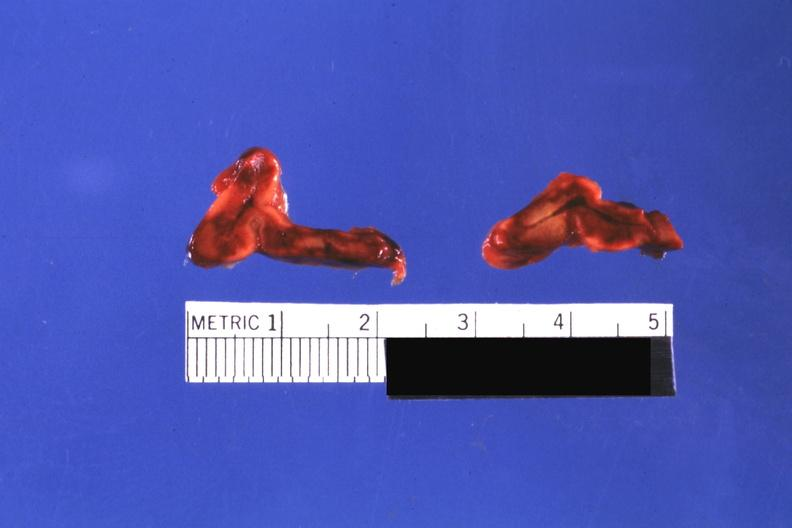what looks like placental abruption?
Answer the question using a single word or phrase. Cut surfaces of both adrenals focal hemorrhagic infarction well shown do not know history 